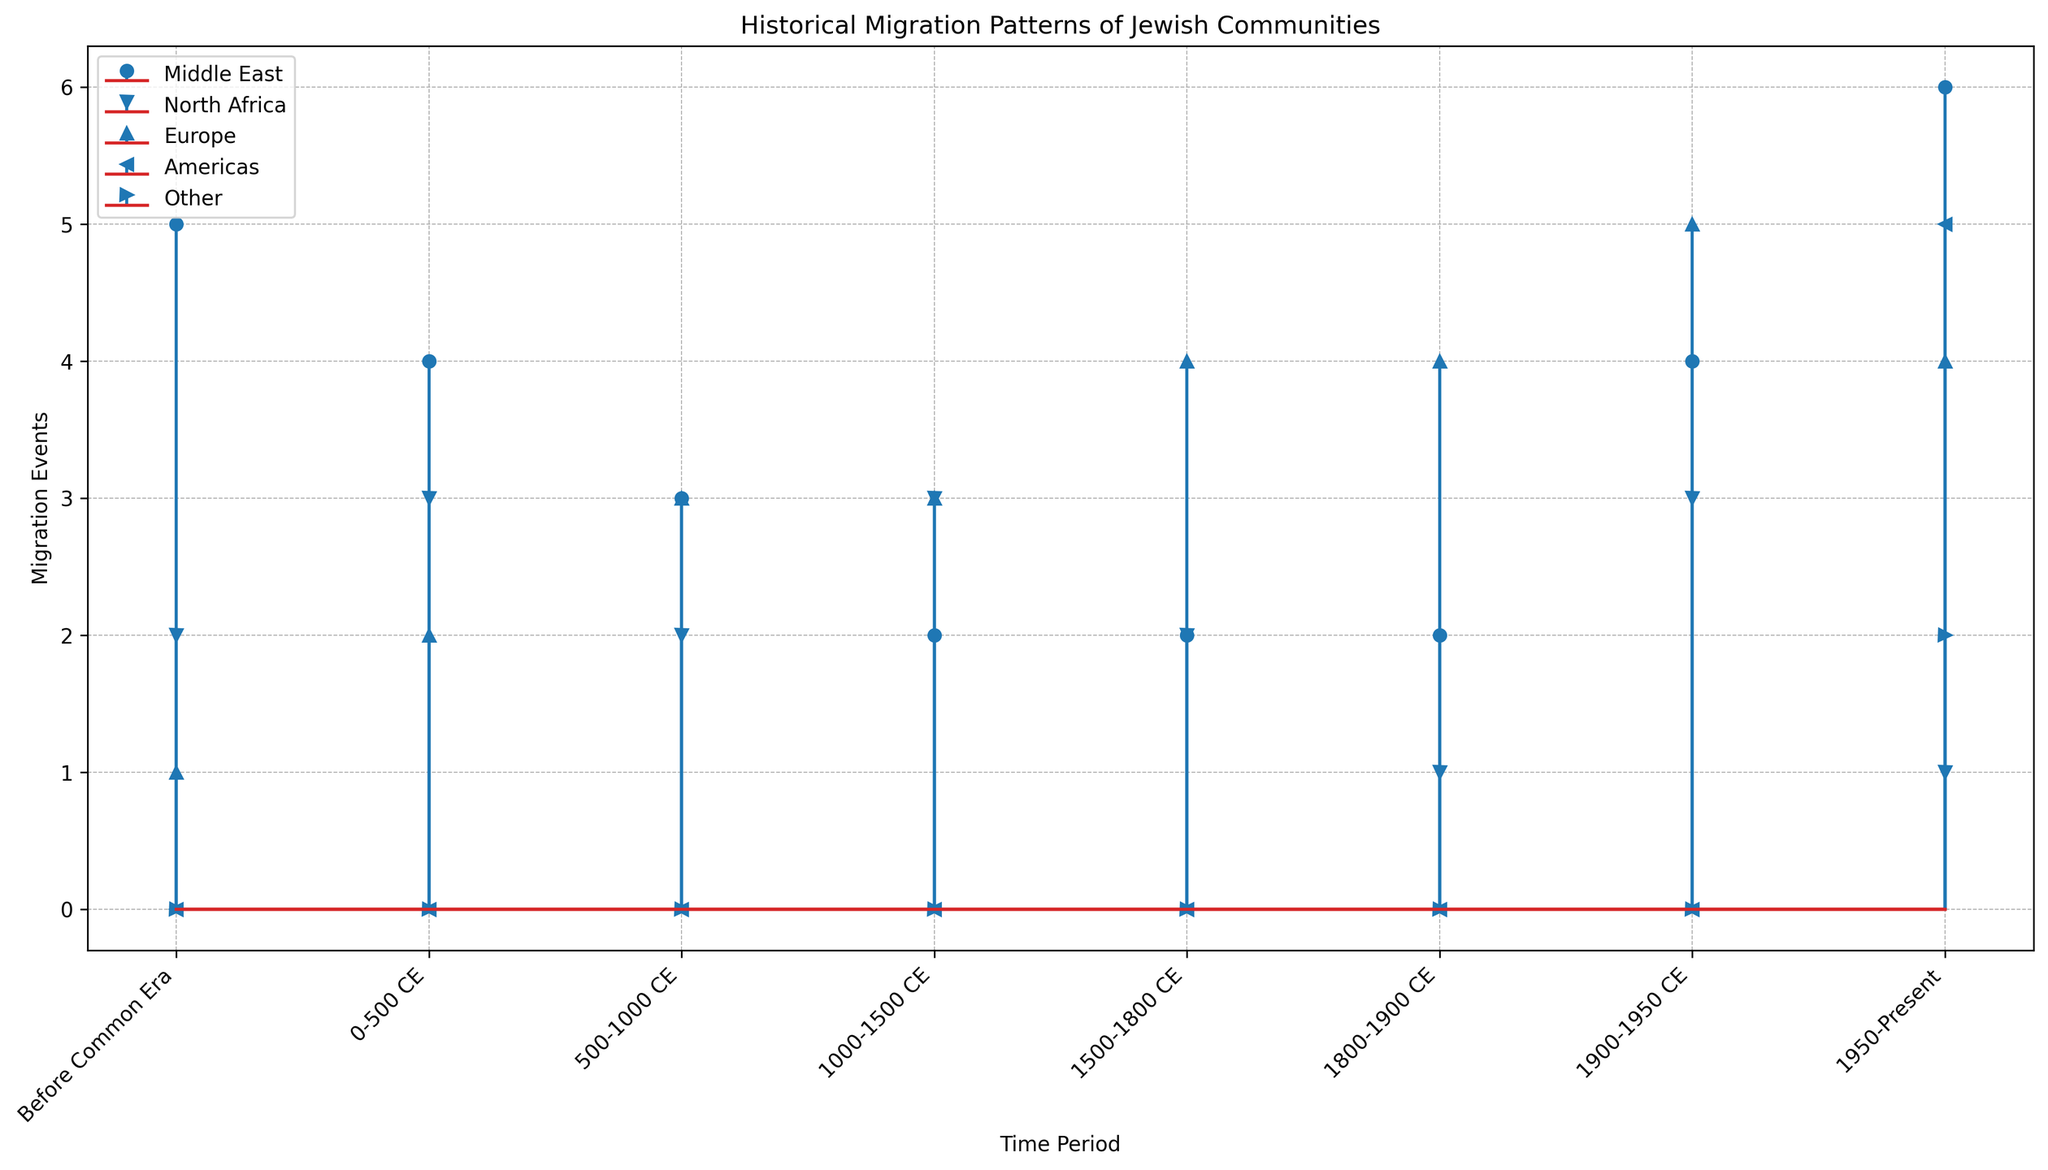What time period had the highest number of migration events for the "Middle East" region? To determine the time period with the highest migration events in the "Middle East" region, look for the highest value in the Middle East's series. The segment labeled "1950-Present" has the highest value of 6.
Answer: 1950-Present Which region experienced the most migration events during the "Before Common Era" period? Compare the values of migration events for all regions during the "Before Common Era" period. The Middle East had the highest value at 5.
Answer: Middle East Compare the total migration events for "Europe" and "North Africa" during the "1900-1950 CE" period. Which one had more events? Check the values for "Europe" and "North Africa" during the "1900-1950 CE" period. Europe had 5 events while North Africa had 3 events.
Answer: Europe What is the sum of migration events for all regions in the “1500-1800 CE” period? Sum up the values for all regions during the "1500-1800 CE" period: Middle East (2) + North Africa (2) + Europe (4) equals 8.
Answer: 8 During which time period did the "Americas" region start experiencing migration events? Identify the period where the "Americas" region begins showing migration values. This starts at "1950-Present" with 5 events.
Answer: 1950-Present By visual comparison, in which time period did the "Middle East" region see a significant increase in migration events compared to its previous period? Compare the values visually for the Middle East across consecutive periods. A notable increase is observed from "1800-1900 CE" (2 events) to "1900-1950 CE" (4 events).
Answer: 1900-1950 CE Calculate the average number of migration events for "Europe" over all time periods. Sum the values for Europe across all periods: 1 + 2 + 3 + 3 + 4 + 4 + 5 + 4 = 26. There are 8 time periods, so 26/8 = 3.25.
Answer: 3.25 During the "1950-Present" period, which region had the second-largest number of migration events? Sort the values for the "1950-Present" period: Middle East (6), North Africa (1), Europe (4), Americas (5), Other (2). The second largest value is 5 for the Americas.
Answer: Americas Which time period shows the lowest migration activity for the "North Africa" region? Identify the period with the smallest value for "North Africa". The "1800-1900 CE" period has the lowest value with 1 event.
Answer: 1800-1900 CE Examine the trend of migration events for "Europe" across all time periods. Did the number of events generally increase, decrease, or have no specific trend? Plot the values for Europe across all periods: 1, 2, 3, 3, 4, 4, 5, 4. The general trend shows an increase, peaking at 5 in "1900-1950 CE" and a slight decrease after.
Answer: Generally increased 